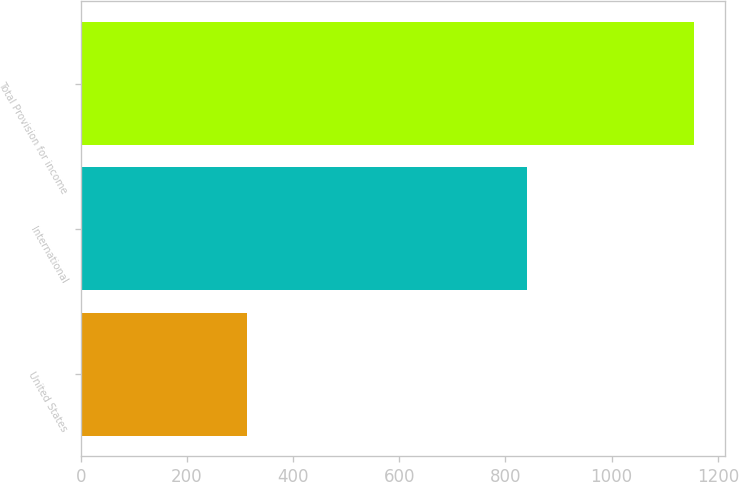Convert chart. <chart><loc_0><loc_0><loc_500><loc_500><bar_chart><fcel>United States<fcel>International<fcel>Total Provision for income<nl><fcel>314<fcel>841<fcel>1155<nl></chart> 